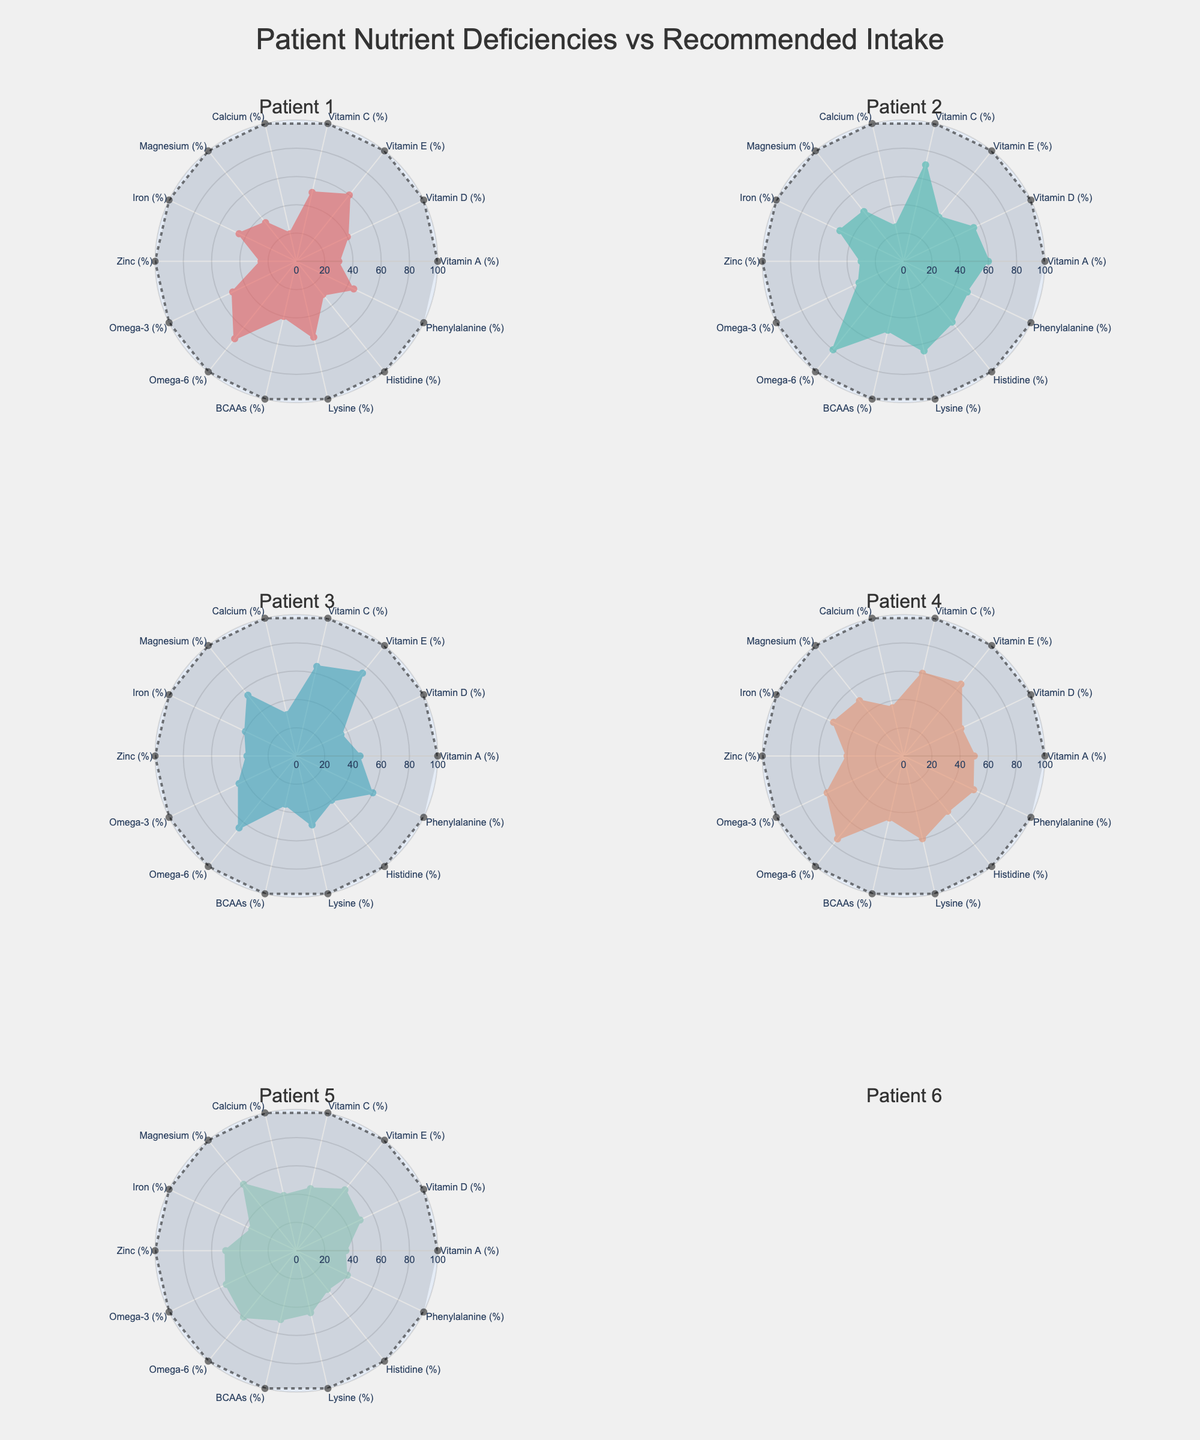What is the title of the figure? The title can be found at the top of the figure, which is "Patient Nutrient Deficiencies vs Recommended Intake".
Answer: Patient Nutrient Deficiencies vs Recommended Intake Which patient has the highest deficiency in Vitamin E? To determine this, look at the deficiency values for Vitamin E across all patients. Patient 3 has a deficiency of 75%, which is the highest among all patients.
Answer: Patient 3 What is the average deficiency in Vitamin D for Patient 2 and Patient 5? To calculate the average, add the deficiencies for Vitamin D of Patient 2 (55%) and Patient 5 (50%), then divide by 2. The calculation is (55 + 50) / 2 = 52.5.
Answer: 52.5 Which nutrient shows the least deficiency for Patient 1? Check each nutrient's deficiency values for Patient 1 and identify the lowest value. The lowest deficiency is observed in Calcium at 20%.
Answer: Calcium How does Patient 4’s histidine deficiency compare to Patient 5’s histidine deficiency? Compare the histidine deficiency values for both patients. Patient 4 has a histidine deficiency of 50%, while Patient 5 has 35%. Patient 4 has a higher deficiency.
Answer: Patient 4’s histidine deficiency is higher For Patient 1, what is the difference between the deficiency in Omega-6 and Omega-3? Subtract the Omega-3 deficiency (50%) from the Omega-6 deficiency (70%) for Patient 1. The difference is 70 - 50 = 20.
Answer: 20 Which patient has the highest deficiency in BCAAs and what is the percentage? Review the BCAAs deficiency for all patients. Patient 2 has the highest deficiency at 50%.
Answer: Patient 2, 50% Is there any nutrient where all patients have a deficiency of more than 30%? Check each nutrient's deficiency values for all patients. For Vitamin A, all patients have deficiencies greater than 30%.
Answer: Vitamin A What nutrients have the same deficiency percentage for both Patient 3 and Patient 5? Compare the deficiency values for both patients across all nutrients. Lysine is the same at 50% deficiency for both Patient 3 and 5.
Answer: Lysine 